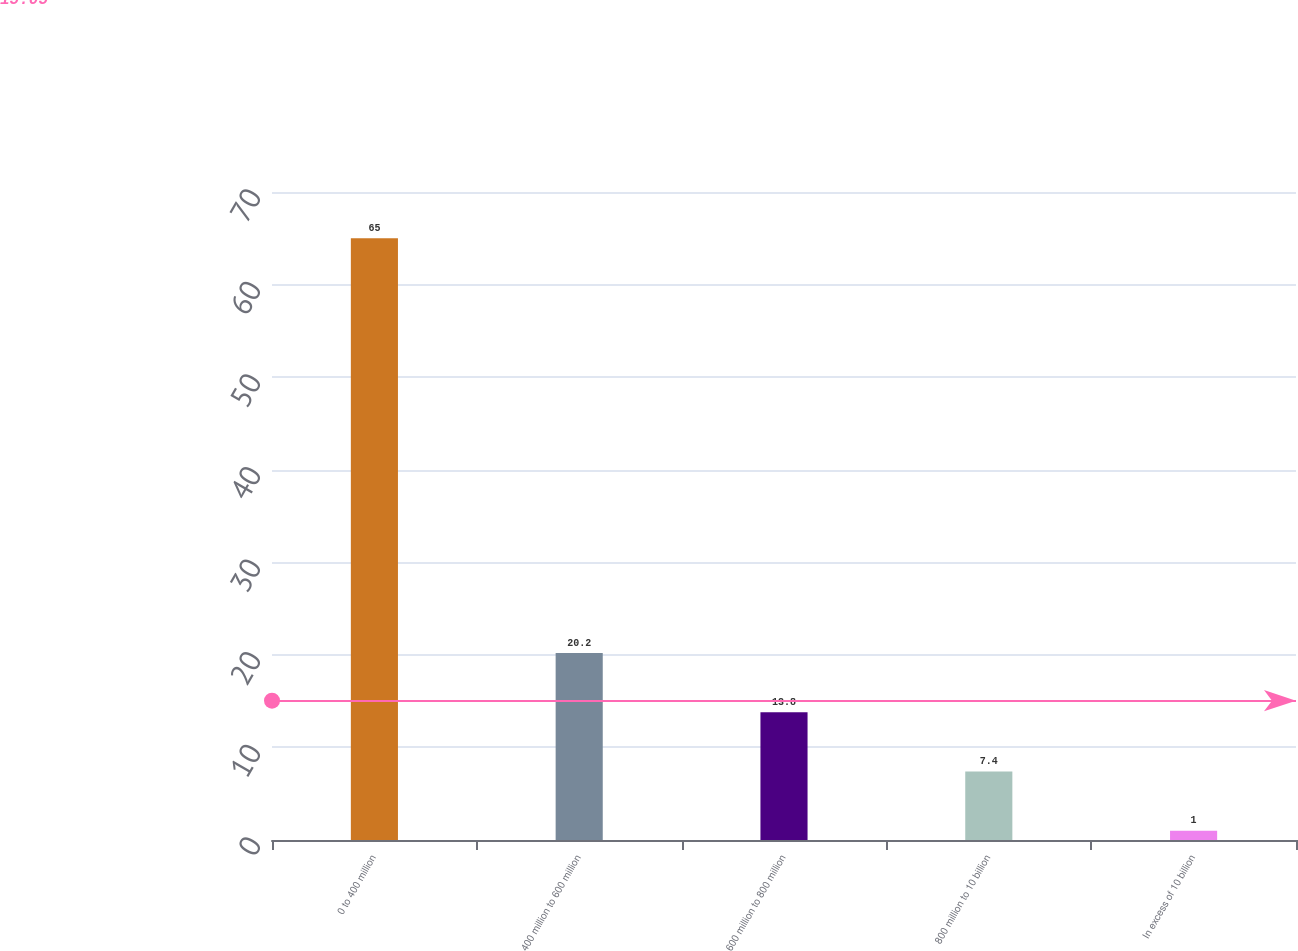Convert chart to OTSL. <chart><loc_0><loc_0><loc_500><loc_500><bar_chart><fcel>0 to 400 million<fcel>400 million to 600 million<fcel>600 million to 800 million<fcel>800 million to 10 billion<fcel>In excess of 10 billion<nl><fcel>65<fcel>20.2<fcel>13.8<fcel>7.4<fcel>1<nl></chart> 